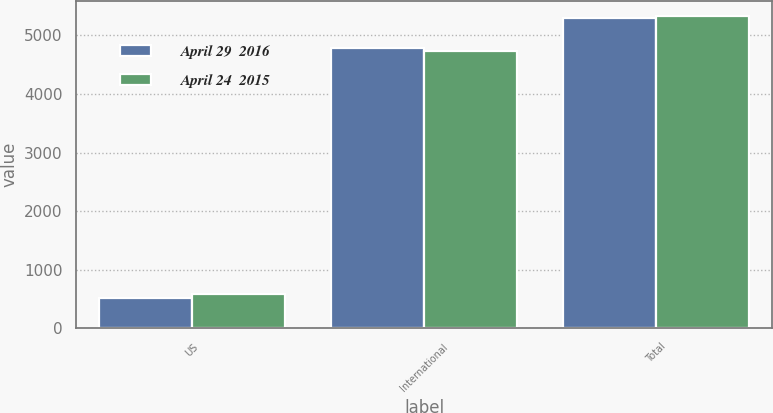Convert chart to OTSL. <chart><loc_0><loc_0><loc_500><loc_500><stacked_bar_chart><ecel><fcel>US<fcel>International<fcel>Total<nl><fcel>April 29  2016<fcel>513<fcel>4790<fcel>5303<nl><fcel>April 24  2015<fcel>596<fcel>4730<fcel>5326<nl></chart> 